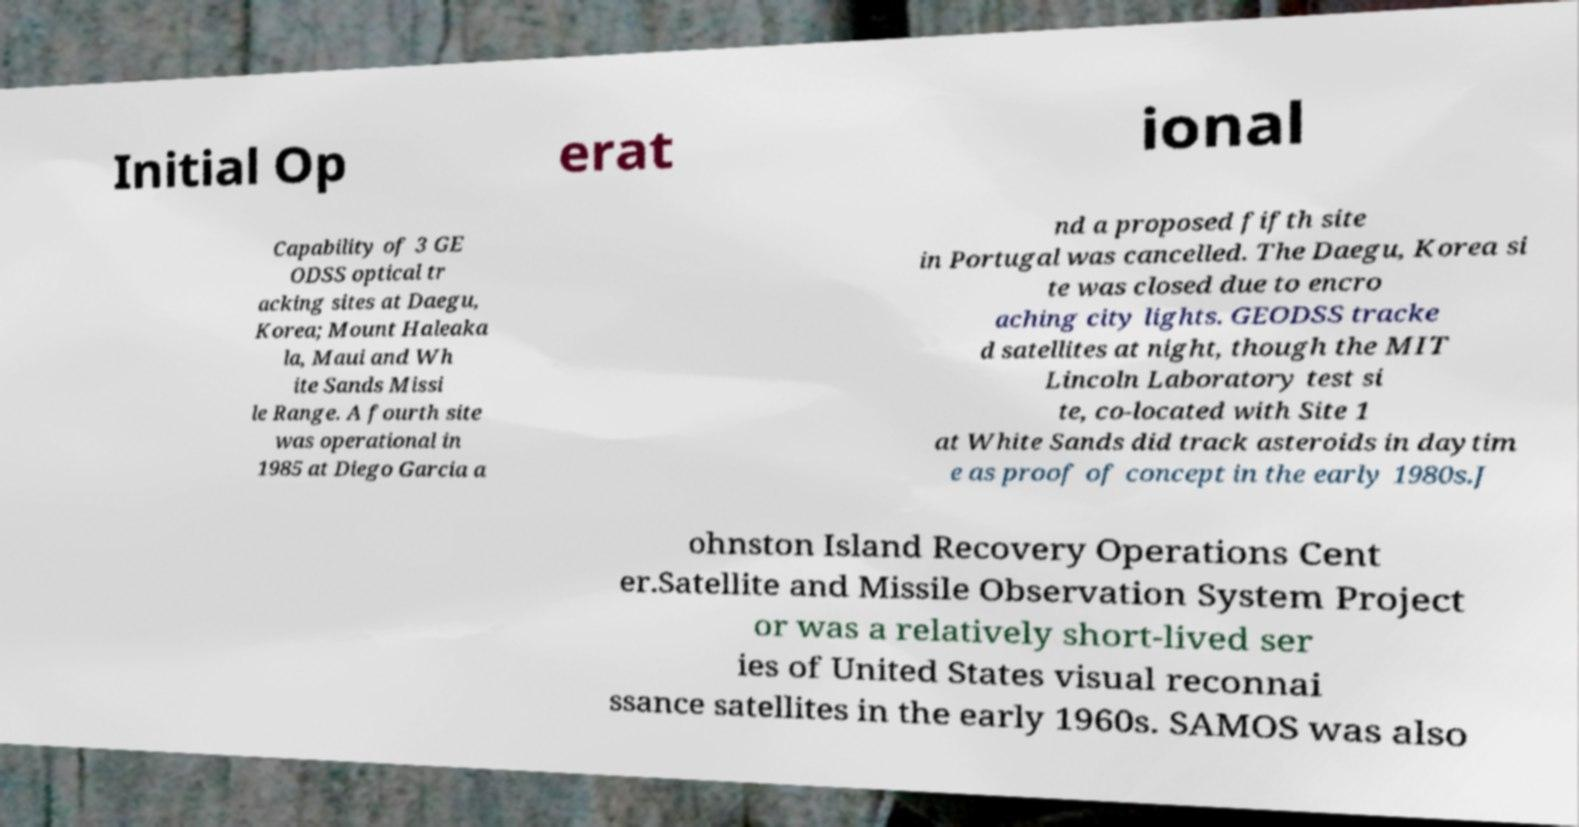Please identify and transcribe the text found in this image. Initial Op erat ional Capability of 3 GE ODSS optical tr acking sites at Daegu, Korea; Mount Haleaka la, Maui and Wh ite Sands Missi le Range. A fourth site was operational in 1985 at Diego Garcia a nd a proposed fifth site in Portugal was cancelled. The Daegu, Korea si te was closed due to encro aching city lights. GEODSS tracke d satellites at night, though the MIT Lincoln Laboratory test si te, co-located with Site 1 at White Sands did track asteroids in daytim e as proof of concept in the early 1980s.J ohnston Island Recovery Operations Cent er.Satellite and Missile Observation System Project or was a relatively short-lived ser ies of United States visual reconnai ssance satellites in the early 1960s. SAMOS was also 